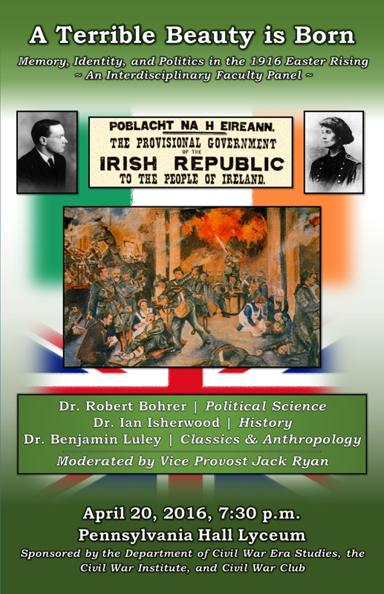Who are the panelists and their respective fields of study? The panelists include Dr. Robert Bohrer, specializing in Political Science, Dr. Ian Isherwood, a scholar of History, and Dr. Benjamin Luley, who combines expertise in Classics and Anthropology. Vice Provost Jack Ryan will moderate the discussion, providing a well-rounded academic exploration of the Easter Rising's effects. 